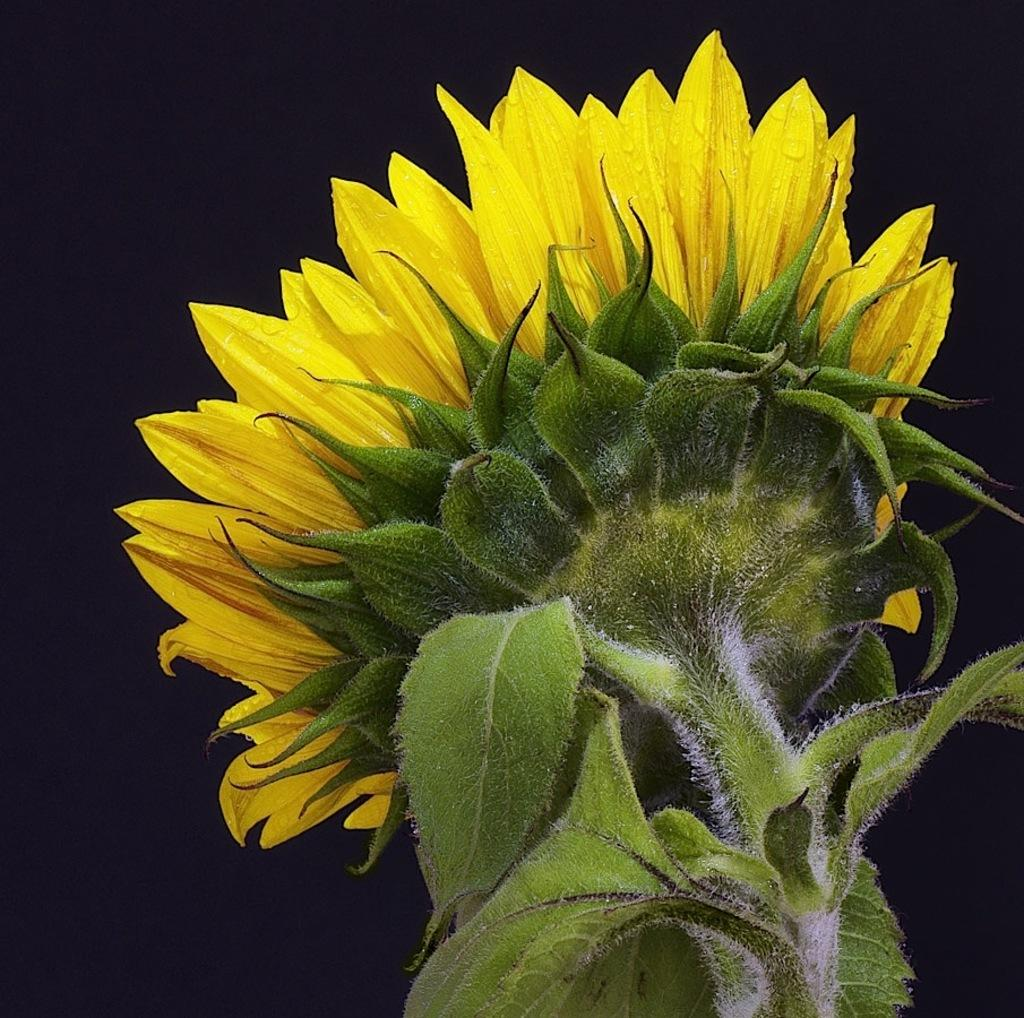What type of plant is in the image? There is a sunflower in the image. What color is the sunflower? The sunflower is yellow in color. What advice does the sunflower give to the viewer in the image? The sunflower does not give any advice in the image, as it is a plant and cannot speak or provide advice. 